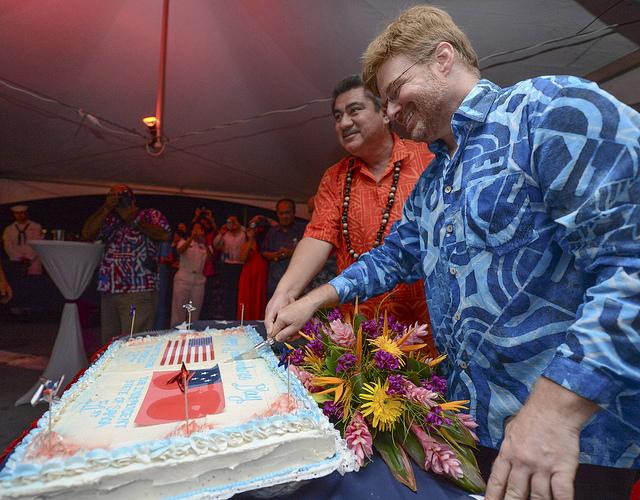Is there an United States flag in the photo?
Quick response, please. Yes. Is this a celebratory occasion?
Short answer required. Yes. What kind of food is being cut?
Short answer required. Cake. 